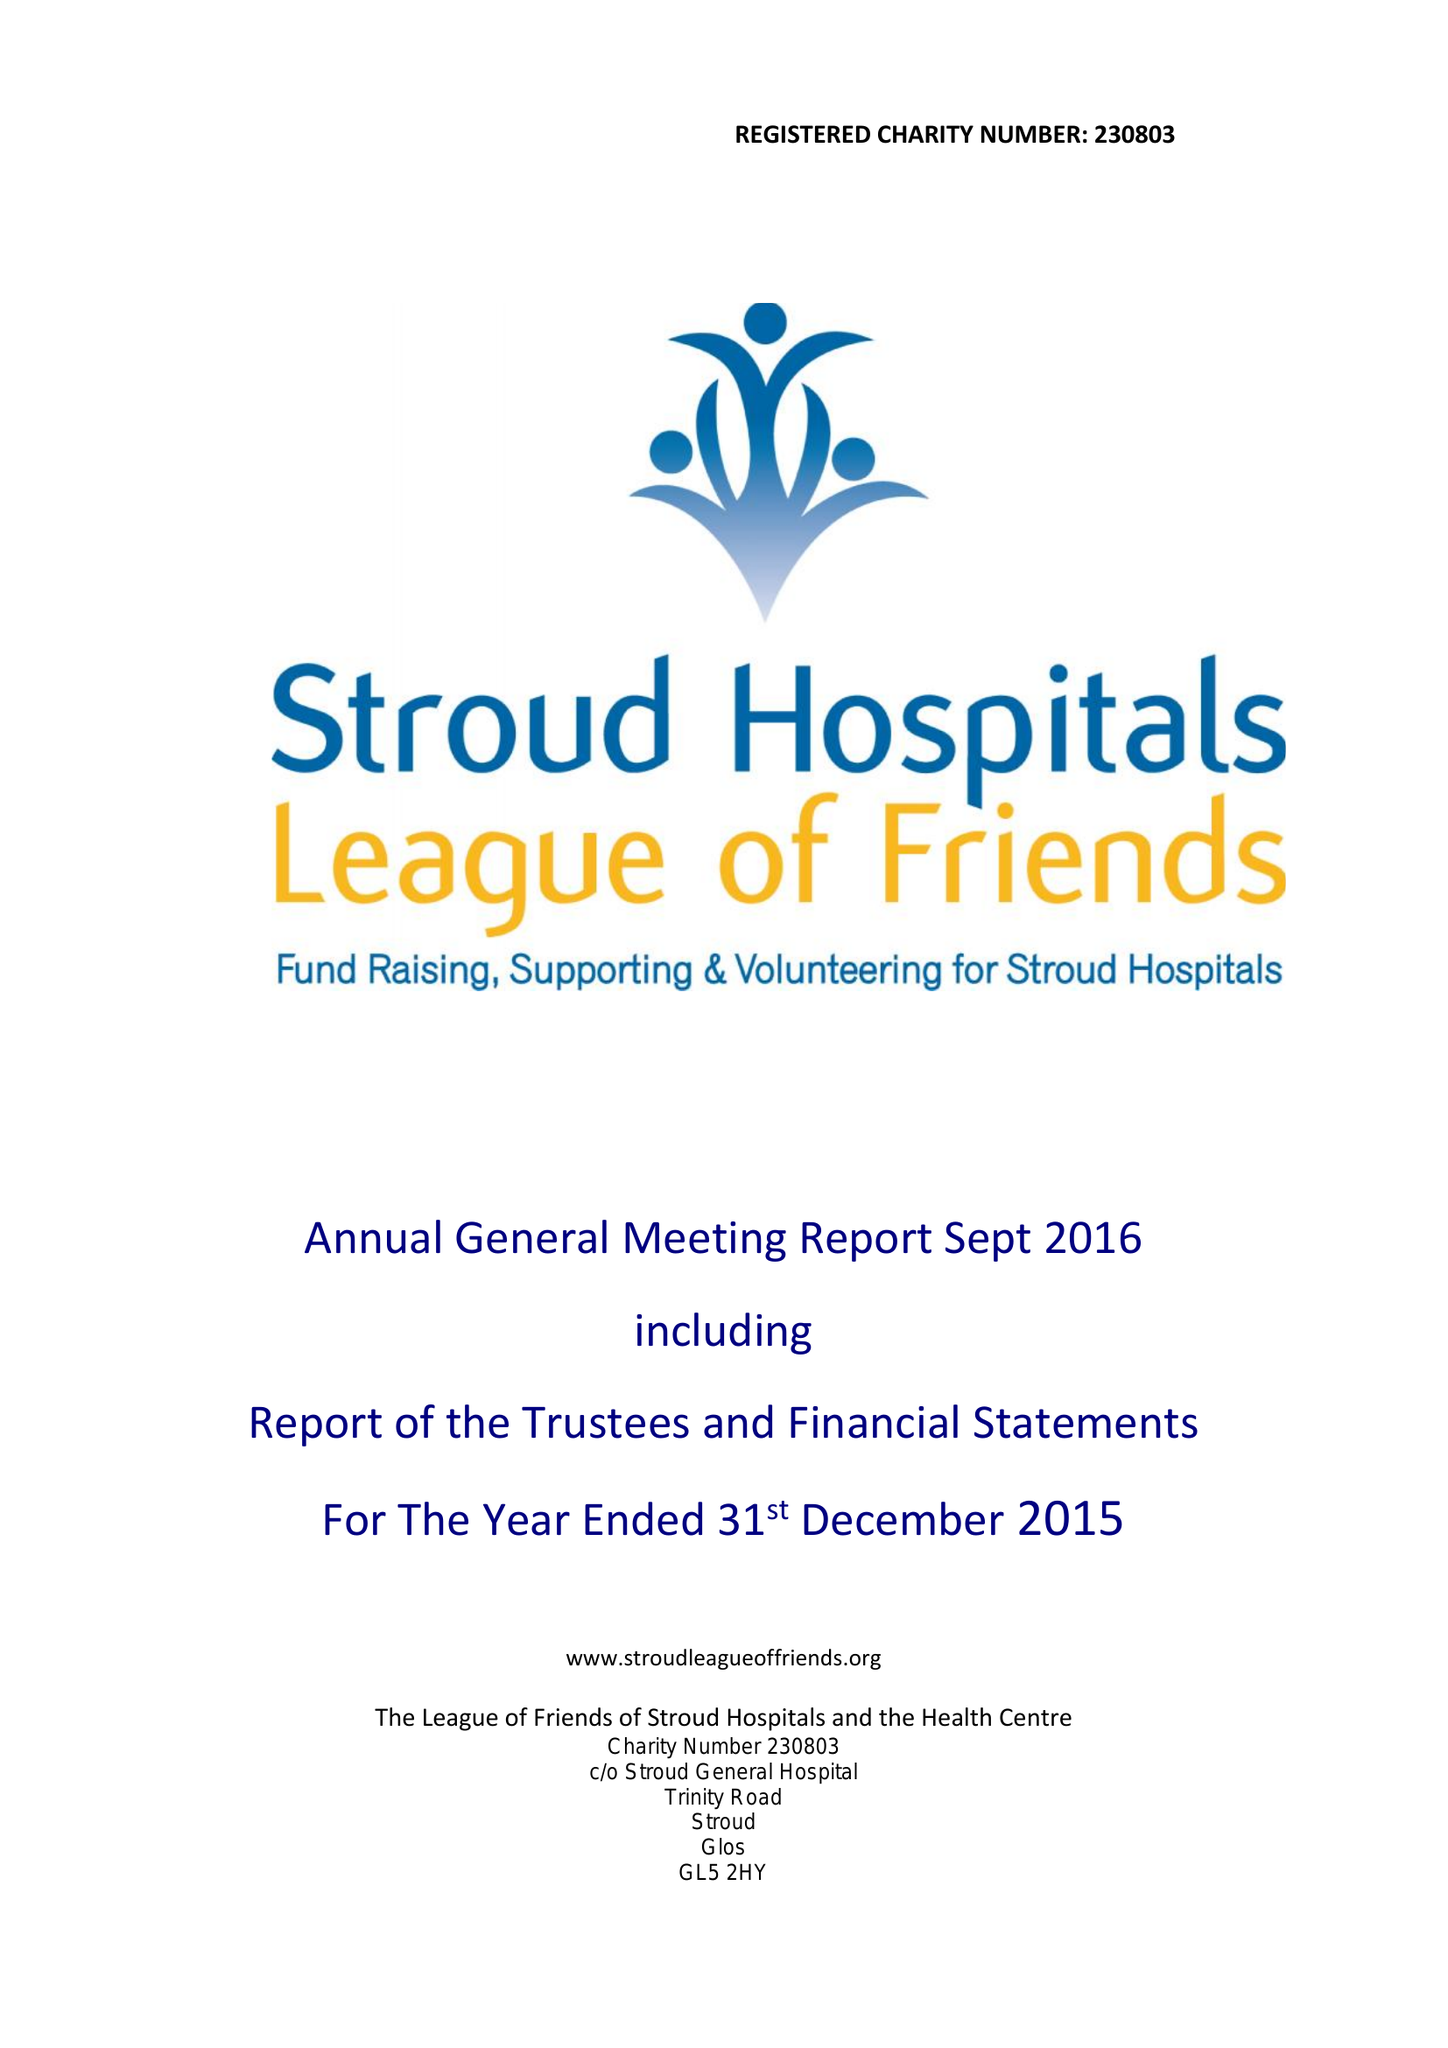What is the value for the report_date?
Answer the question using a single word or phrase. 2015-12-31 